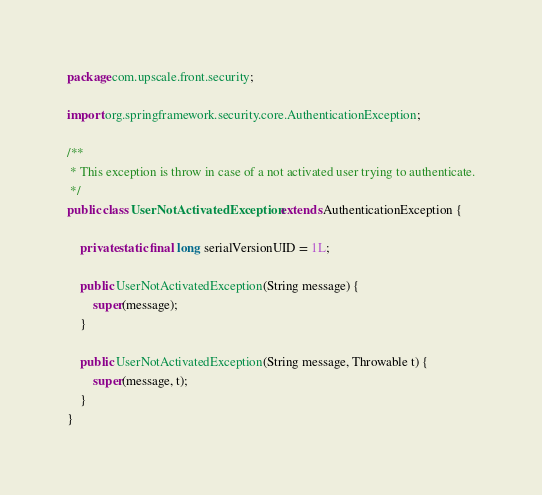Convert code to text. <code><loc_0><loc_0><loc_500><loc_500><_Java_>package com.upscale.front.security;

import org.springframework.security.core.AuthenticationException;

/**
 * This exception is throw in case of a not activated user trying to authenticate.
 */
public class UserNotActivatedException extends AuthenticationException {

    private static final long serialVersionUID = 1L;

    public UserNotActivatedException(String message) {
        super(message);
    }

    public UserNotActivatedException(String message, Throwable t) {
        super(message, t);
    }
}
</code> 